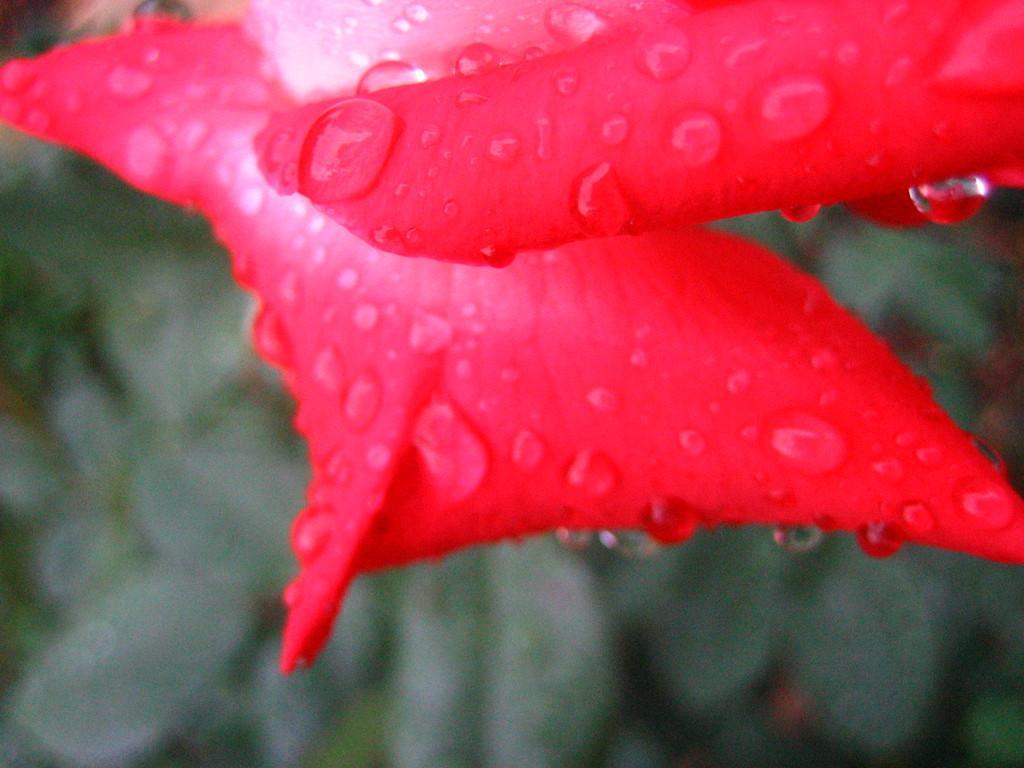Can you describe this image briefly? In the picture we can see a rose petals which are red in color with water droplets on it and behind we can see some plants which are invisible. 